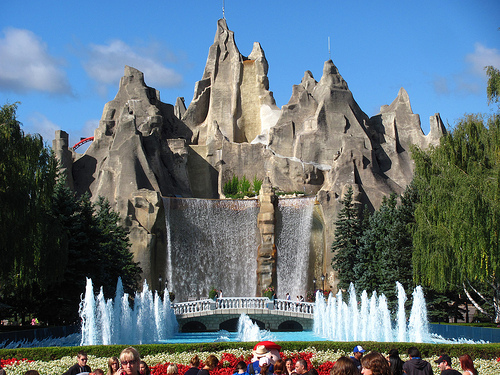<image>
Is the sky behind the peak? Yes. From this viewpoint, the sky is positioned behind the peak, with the peak partially or fully occluding the sky. 